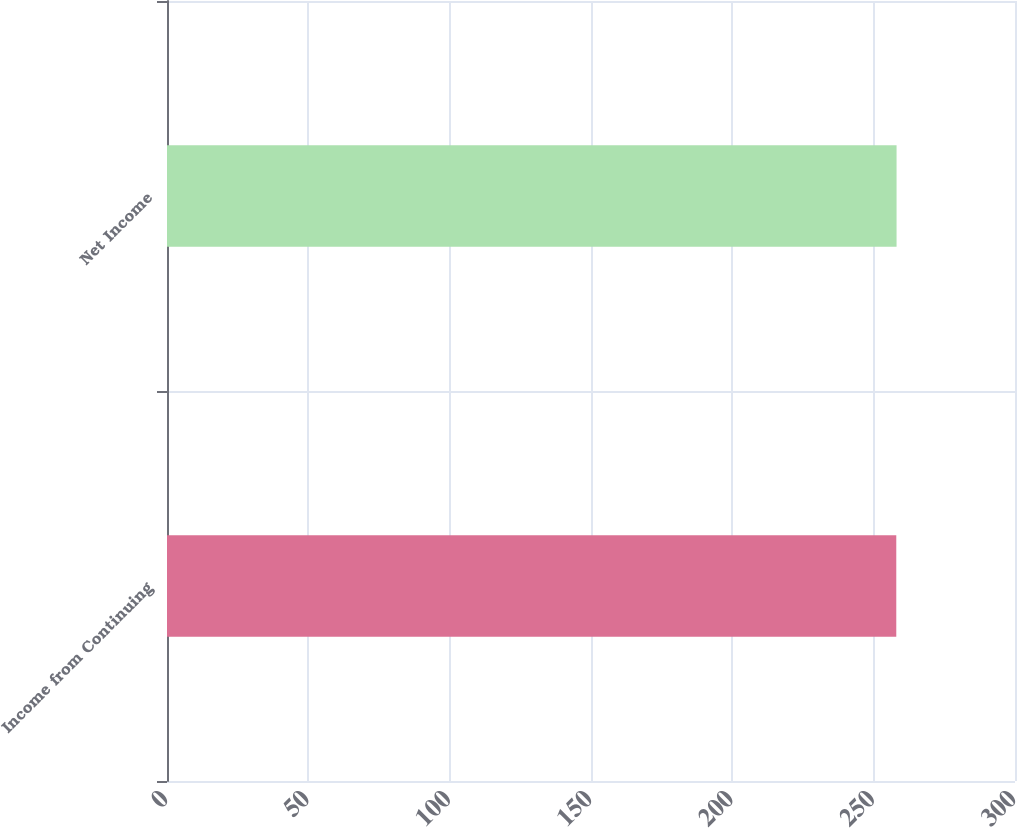<chart> <loc_0><loc_0><loc_500><loc_500><bar_chart><fcel>Income from Continuing<fcel>Net Income<nl><fcel>258<fcel>258.1<nl></chart> 